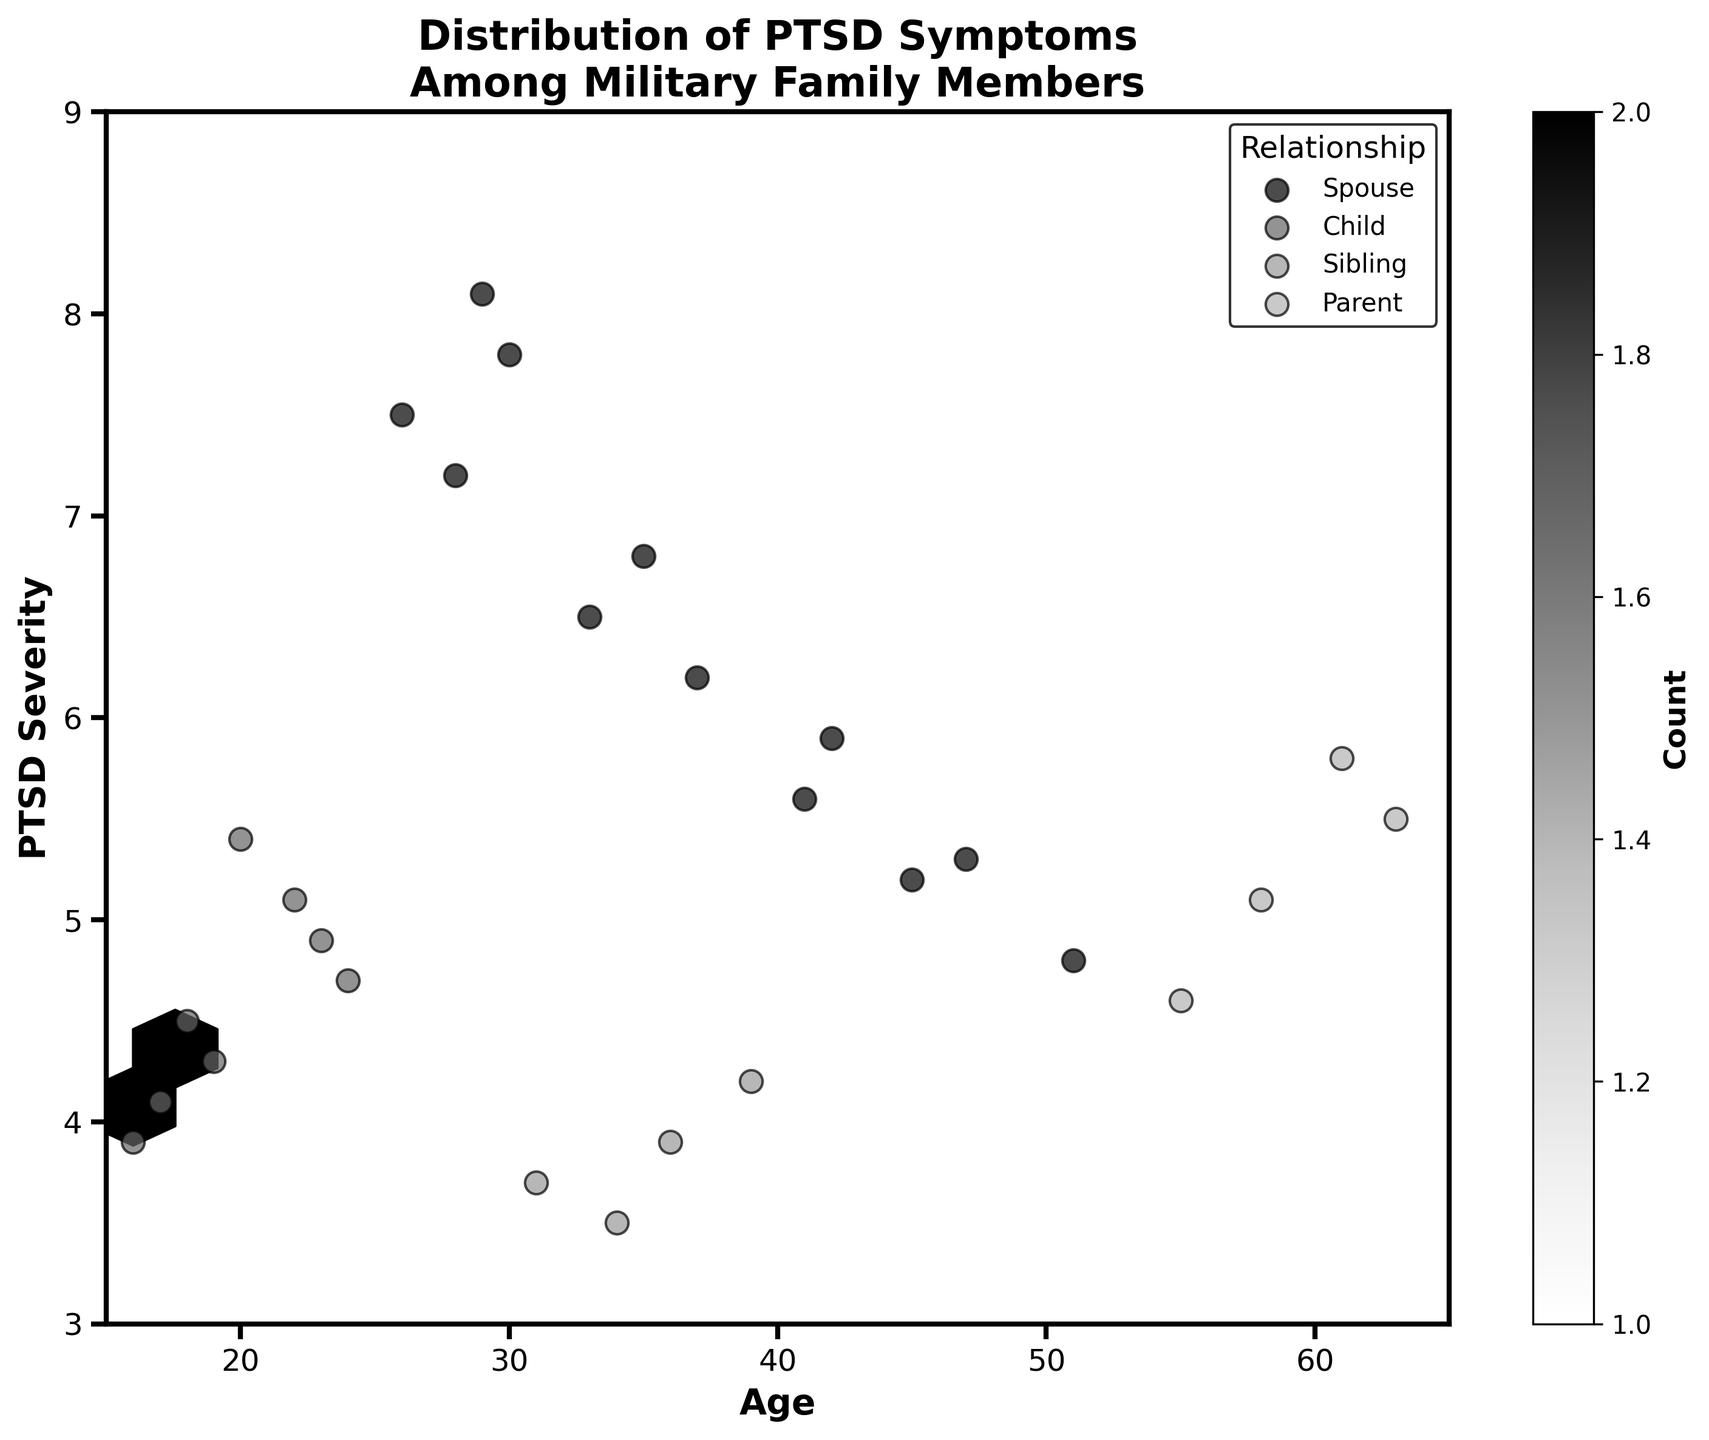What is the title of the figure? The title of the figure is found at the top center and summarizes the data being presented.
Answer: Distribution of PTSD Symptoms Among Military Family Members What does the color intensity in the hexagons represent? In a hexbin plot, the color intensity in the hexagons represents the count of data points that fall within each hexagonal bin. The darker the hexagon, the more data points it contains.
Answer: Count of data points What are the axis labels in the figure? The axis labels are found along the x-axis and y-axis, providing context for the data values plotted.
Answer: Age (x-axis) and PTSD Severity (y-axis) Which relationship to the service member has the highest PTSD severity in the figure? By looking at the scatter points in the figure, identify which relationship reaches the highest PTSD severity value on the y-axis.
Answer: Spouse Are there any data points for 'Child' family members with a PTSD severity above 5.5? Scan the scatter points marked as 'Child' and check if any rise above the 5.5 mark on the y-axis.
Answer: No Which age group shows the widest distribution of PTSD severity? Examine the spread of PTSD severity values across different age groups and determine which age range exhibits the greatest variability.
Answer: Spouse (ages 28 to 51) Which group has the most concentrated cluster of PTSD severity values, and what is the range? Look for densely packed clusters of hexagons and note which relationship group they belong to and the PTSD severity range they cover.
Answer: Child, between 4.1 and 5.4 What is the approximate average PTSD severity for 'Parent' family members? Calculate the mean PTSD severity for all data points marked as 'Parent'. There are 4 Parent data points with PTSD severities of 4.6, 5.8, 5.1, and 5.5. Summing them gives 21 and dividing by 4 gives an average of 5.25.
Answer: 5.25 How does the PTSD severity of 'Sibling' family members compare to that of 'Child' family members? Compare the range and central tendency of PTSD severity values between 'Sibling' and 'Child' groups based on their scatter points. 'Sibling' values range roughly from 3.5 to 4.2, while 'Child' values range roughly from 3.9 to 5.4.
Answer: Sibling shows lower PTSD severity on average than Child Are there any gaps in the age distribution of military family members in the figure? Observe the x-axis to see if there are any age ranges with no data points across all groups. Notable gaps are observed around ages 25, 27, 32, 38, 40, etc.
Answer: Yes, several gaps exist 